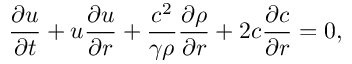Convert formula to latex. <formula><loc_0><loc_0><loc_500><loc_500>\frac { \partial u } { \partial t } + u \frac { \partial u } { \partial r } + \frac { c ^ { 2 } } { \gamma \rho } \frac { \partial \rho } { \partial r } + 2 c \frac { \partial c } { \partial r } = 0 ,</formula> 